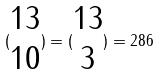<formula> <loc_0><loc_0><loc_500><loc_500>( \begin{matrix} 1 3 \\ 1 0 \end{matrix} ) = ( \begin{matrix} 1 3 \\ 3 \end{matrix} ) = 2 8 6</formula> 